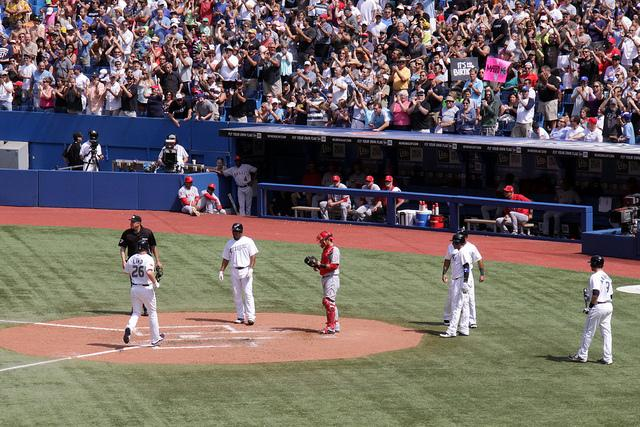What position is the man in red kneepads on the field playing? catcher 